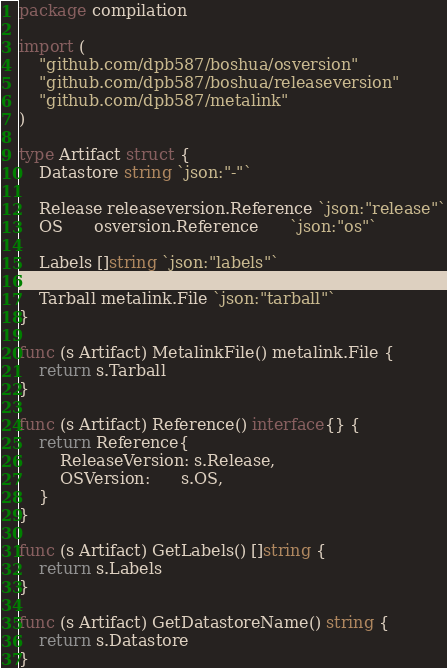<code> <loc_0><loc_0><loc_500><loc_500><_Go_>package compilation

import (
	"github.com/dpb587/boshua/osversion"
	"github.com/dpb587/boshua/releaseversion"
	"github.com/dpb587/metalink"
)

type Artifact struct {
	Datastore string `json:"-"`

	Release releaseversion.Reference `json:"release"`
	OS      osversion.Reference      `json:"os"`

	Labels []string `json:"labels"`

	Tarball metalink.File `json:"tarball"`
}

func (s Artifact) MetalinkFile() metalink.File {
	return s.Tarball
}

func (s Artifact) Reference() interface{} {
	return Reference{
		ReleaseVersion: s.Release,
		OSVersion:      s.OS,
	}
}

func (s Artifact) GetLabels() []string {
	return s.Labels
}

func (s Artifact) GetDatastoreName() string {
	return s.Datastore
}
</code> 